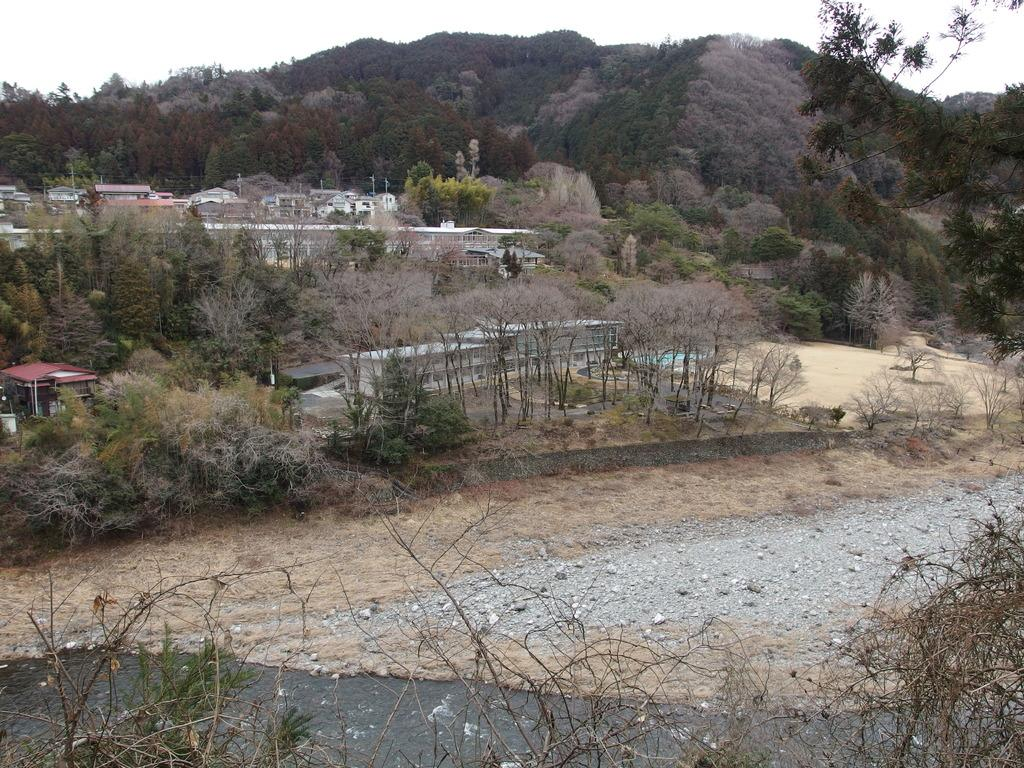What is present in the image that is related to water? There is water in the image. What other substance can be seen in the image? There is mud in the image. What can be seen in the distance in the image? There are trees and buildings in the background of the image. What part of the natural environment is visible in the image? The sky is visible in the background of the image. What type of current is flowing through the market in the image? There is no market or current present in the image. Can you tell me the name of the judge overseeing the trial in the image? There is no trial or judge present in the image. 